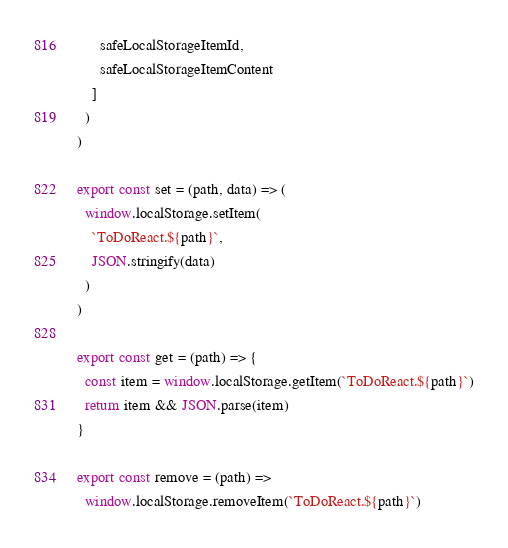<code> <loc_0><loc_0><loc_500><loc_500><_JavaScript_>      safeLocalStorageItemId,
      safeLocalStorageItemContent
    ]
  )
)

export const set = (path, data) => (
  window.localStorage.setItem(
    `ToDoReact.${path}`,
    JSON.stringify(data)
  )
)

export const get = (path) => {
  const item = window.localStorage.getItem(`ToDoReact.${path}`)
  return item && JSON.parse(item)
}

export const remove = (path) =>
  window.localStorage.removeItem(`ToDoReact.${path}`)
</code> 